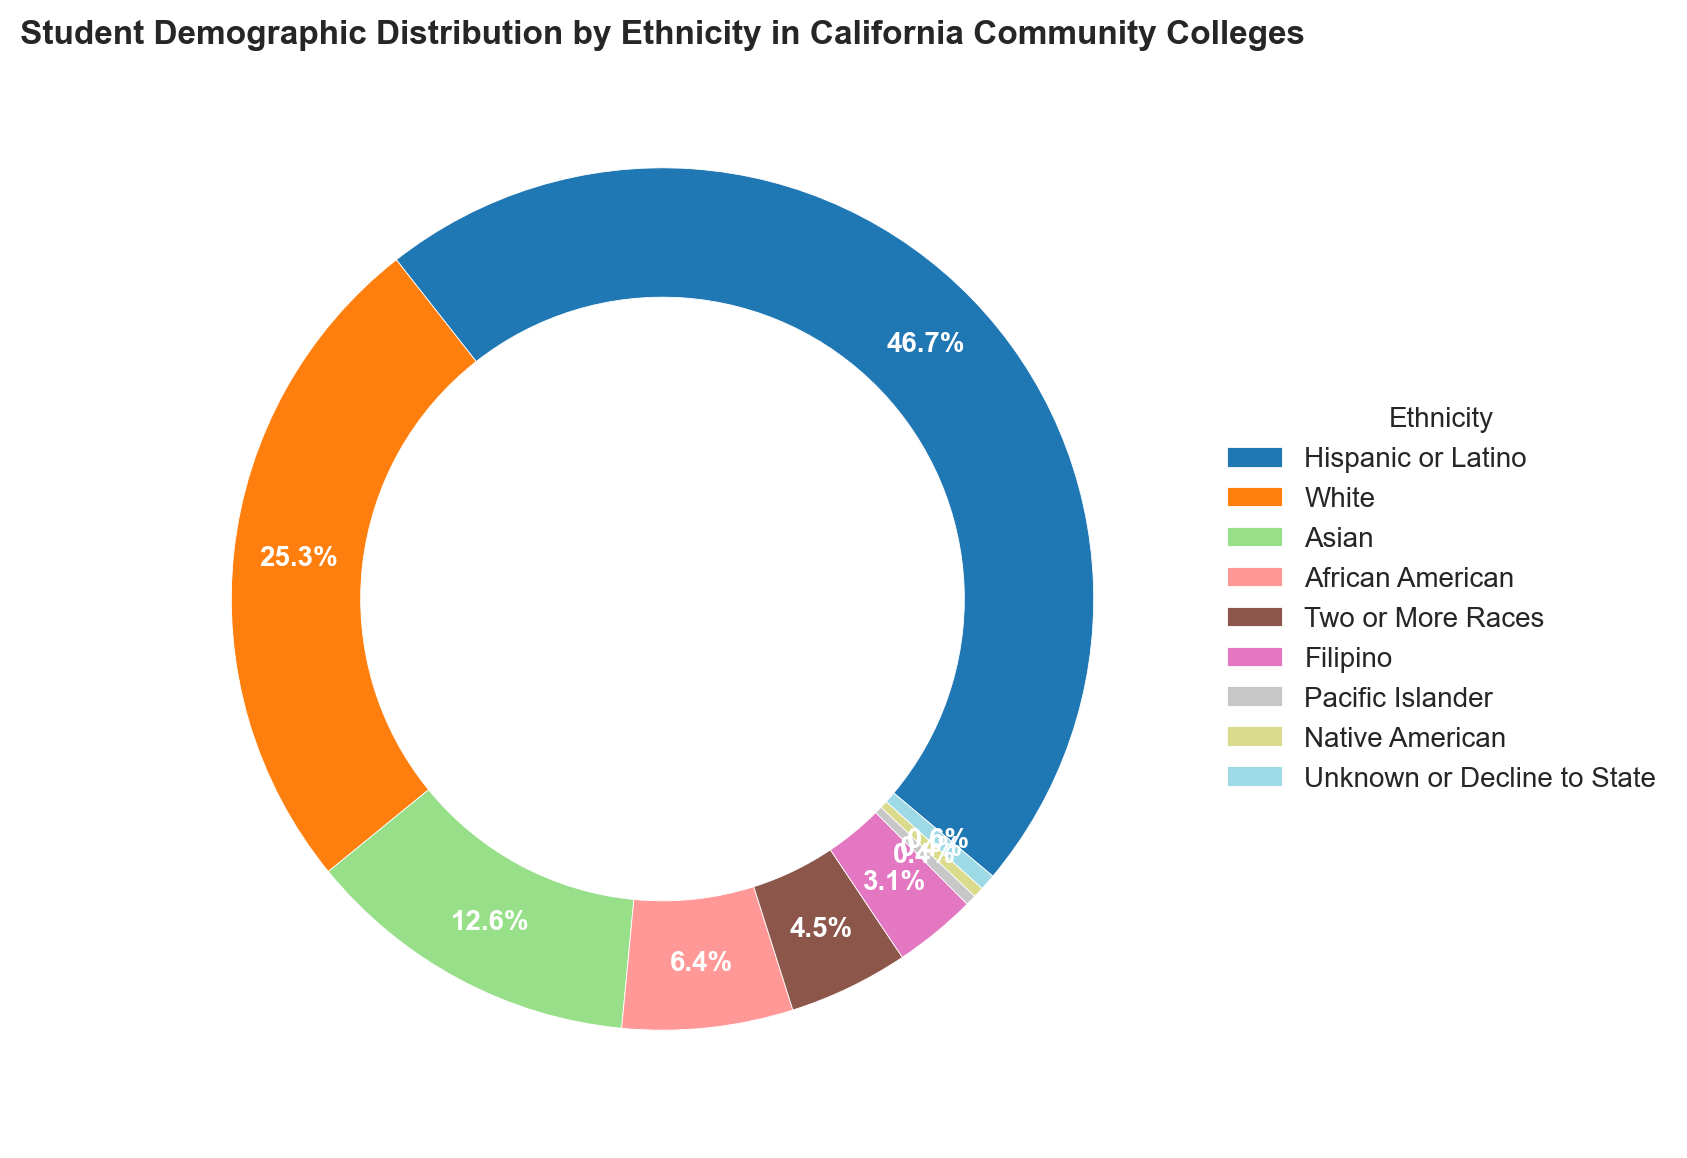What is the largest ethnic group in California Community Colleges? By visually inspecting the ring chart, we can see that the largest segment belongs to the "Hispanic or Latino" group. This is also indicated by the percentage label which shows 46.7%.
Answer: Hispanic or Latino Which ethnic group is the smallest in terms of student demographic percentage? The smallest segment on the ring chart represents both "Pacific Islander" and "Native American" groups, each with a percentage of 0.4%.
Answer: Pacific Islander and Native American How do the percentages of the African American and Asian ethnic groups compare? From the ring chart, we can see that the percentage for the African American group is 6.4%, whereas it is 12.6% for the Asian group. Clearly, the percentage is higher for the Asian group.
Answer: Asian group has a higher percentage What is the combined percentage for groups with a population share less than 5%? By summing up the percentages for each ethnic group with less than 5%: African American (6.4), Two or More Races (4.5), Filipino (3.1), Pacific Islander (0.4), Native American (0.4), Unknown or Decline to State (0.6), we get 4.5 + 3.1 + 0.4 + 0.4 + 0.6 = 9.0%
Answer: 9.0% Is the percentage of Hispanic or Latino students higher or lower than 40%? By referring to the chart, the percentage for the Hispanic or Latino group is 46.7%, which is higher than 40%.
Answer: Higher Which color segment represents the White ethnic group and what is its percentage? The White ethnic group is represented by a distinct color in the ring chart. Their segment shows a percentage of 25.3%.
Answer: 25.3% How many ethnic groups have a percentage higher than 10%? By inspecting the ring chart, we find that three ethnic groups surpass 10%: Hispanic or Latino (46.7%), White (25.3%), and Asian (12.6%).
Answer: Three What is the approximate size difference between the Hispanic or Latino group and the African American group? The percentage for Hispanic or Latino is 46.7%, and for African American, it is 6.4%. Subtracting these gives us 46.7 - 6.4 = 40.3%.
Answer: 40.3% If you were to combine the percentages of the Asian and White ethnic groups, what would the total be? Adding the percentages for Asian (12.6%) and White (25.3%) results in a combined total of 12.6 + 25.3 = 37.9%.
Answer: 37.9% What is the percentage of the Unknown or Decline to State ethnic group, and how is it visually represented on the chart? The ring chart shows a small color segment for the Unknown or Decline to State group, labeled as 0.6%.
Answer: 0.6% 